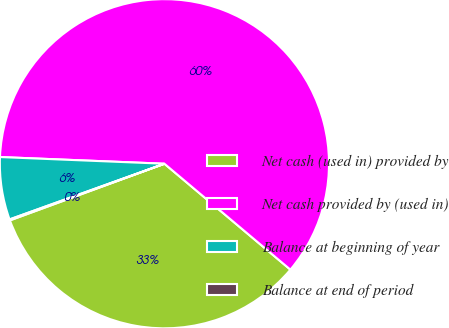<chart> <loc_0><loc_0><loc_500><loc_500><pie_chart><fcel>Net cash (used in) provided by<fcel>Net cash provided by (used in)<fcel>Balance at beginning of year<fcel>Balance at end of period<nl><fcel>33.28%<fcel>60.48%<fcel>6.14%<fcel>0.1%<nl></chart> 